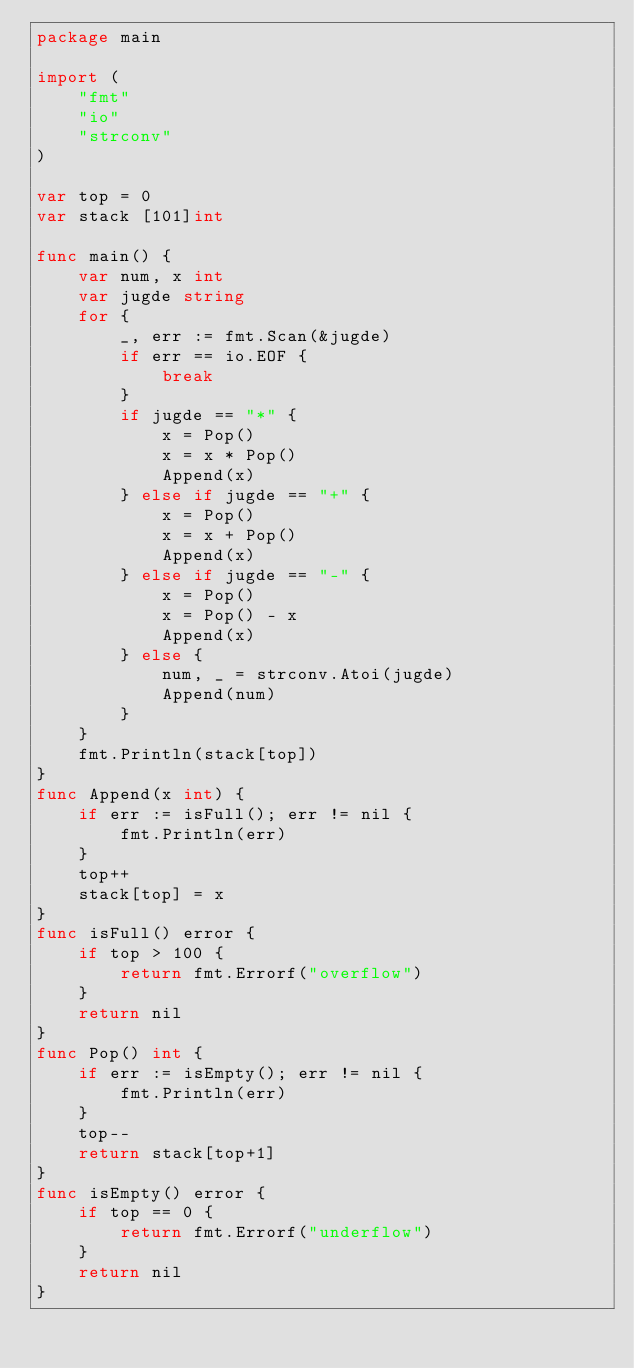Convert code to text. <code><loc_0><loc_0><loc_500><loc_500><_Go_>package main

import (
	"fmt"
	"io"
	"strconv"
)

var top = 0
var stack [101]int

func main() {
	var num, x int
	var jugde string
	for {
		_, err := fmt.Scan(&jugde)
		if err == io.EOF {
			break
		}
		if jugde == "*" {
			x = Pop()
			x = x * Pop()
			Append(x)
		} else if jugde == "+" {
			x = Pop()
			x = x + Pop()
			Append(x)
		} else if jugde == "-" {
			x = Pop()
			x = Pop() - x
			Append(x)
		} else {
			num, _ = strconv.Atoi(jugde)
			Append(num)
		}
	}
	fmt.Println(stack[top])
}
func Append(x int) {
	if err := isFull(); err != nil {
		fmt.Println(err)
	}
	top++
	stack[top] = x
}
func isFull() error {
	if top > 100 {
		return fmt.Errorf("overflow")
	}
	return nil
}
func Pop() int {
	if err := isEmpty(); err != nil {
		fmt.Println(err)
	}
	top--
	return stack[top+1]
}
func isEmpty() error {
	if top == 0 {
		return fmt.Errorf("underflow")
	}
	return nil
}

</code> 